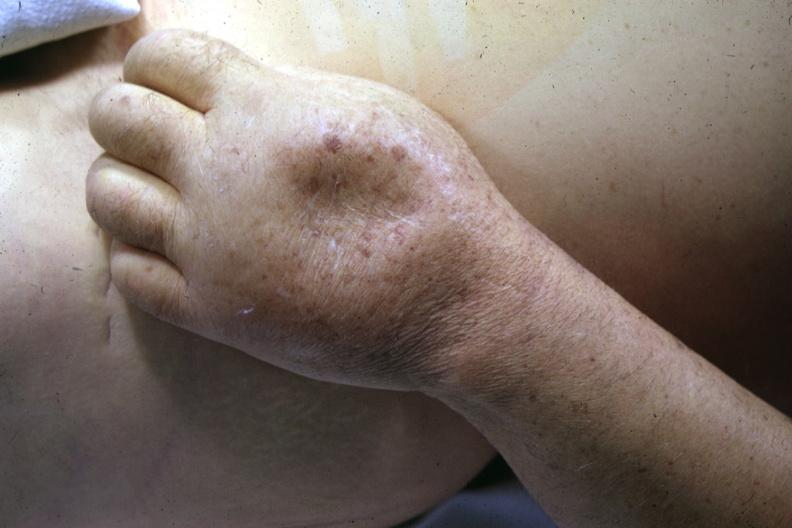does this image show close-up of dorsum of hand with marked pitting edema good example?
Answer the question using a single word or phrase. Yes 